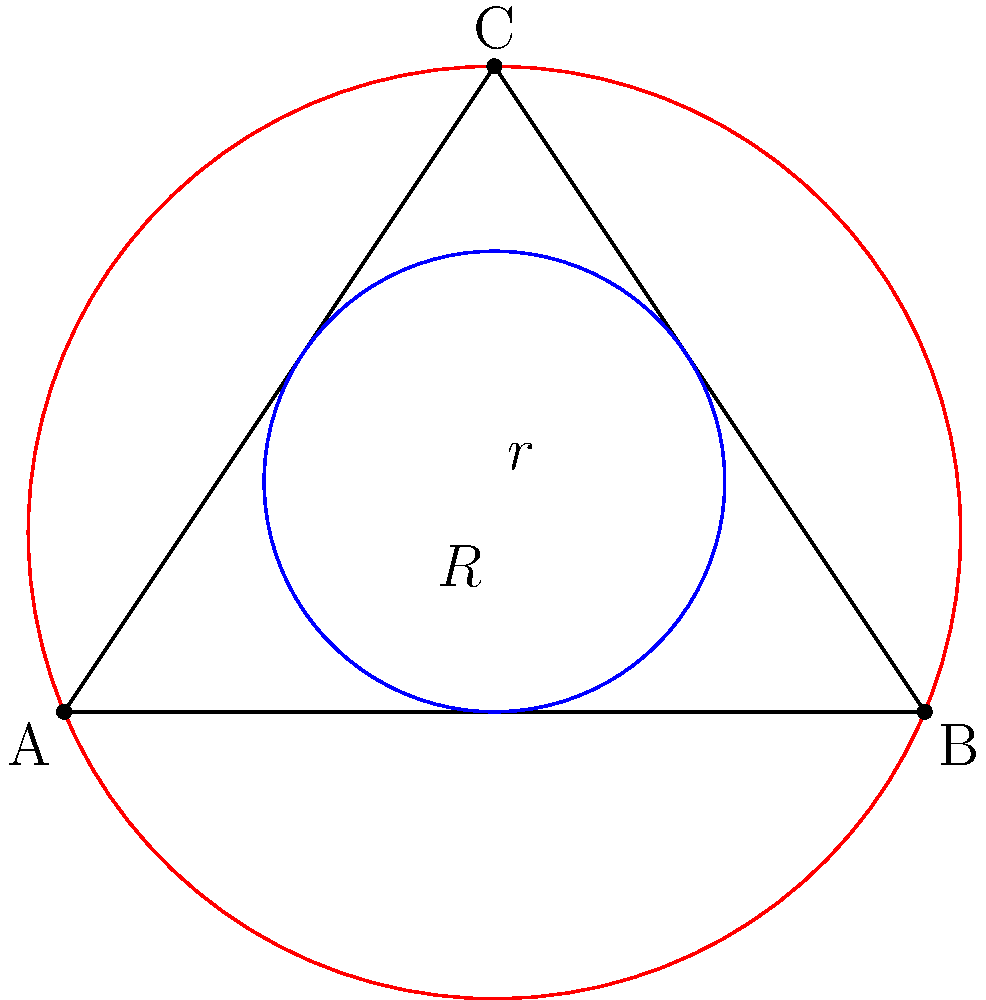In the triangle ABC shown above, let $r$ be the radius of the inscribed circle (blue) and $R$ be the radius of the circumscribed circle (red). If the area of the triangle is 6 square units and its perimeter is 12 units, what is the value of $\frac{R}{r}$? (Hint: Consider the relationship between the area, perimeter, and radii of inscribed and circumscribed circles in a triangle.) Let's approach this step-by-step:

1) For any triangle, the area $A$ is related to the inradius $r$ and semiperimeter $s$ by the formula:
   $A = rs$

2) The semiperimeter $s$ is half the perimeter. Given the perimeter is 12 units:
   $s = 12/2 = 6$ units

3) We're given that the area $A$ is 6 square units. Using the formula from step 1:
   $6 = r * 6$
   $r = 1$ unit

4) For any triangle, the area $A$ is also related to the circumradius $R$ and sides $a$, $b$, $c$ by the formula:
   $A = \frac{abc}{4R}$

5) We don't know the individual side lengths, but we know their sum (the perimeter) is 12. Let's call the sides $x$, $y$, and $z$. Then:
   $x + y + z = 12$
   $xyz = 6 * 4R = 24R$

6) By the arithmetic mean-geometric mean inequality:
   $(\frac{x+y+z}{3})^3 \geq xyz$
   $(4)^3 \geq 24R$
   $64 \geq 24R$
   $R \leq \frac{8}{3}$

7) The equality holds when the triangle is equilateral, which is our case (as it maximizes the area for a given perimeter). Therefore:
   $R = \frac{8}{3}$

8) Now we can calculate $\frac{R}{r}$:
   $\frac{R}{r} = \frac{8/3}{1} = \frac{8}{3}$

Thus, the ratio of the circumradius to the inradius is 8:3.
Answer: $\frac{8}{3}$ 